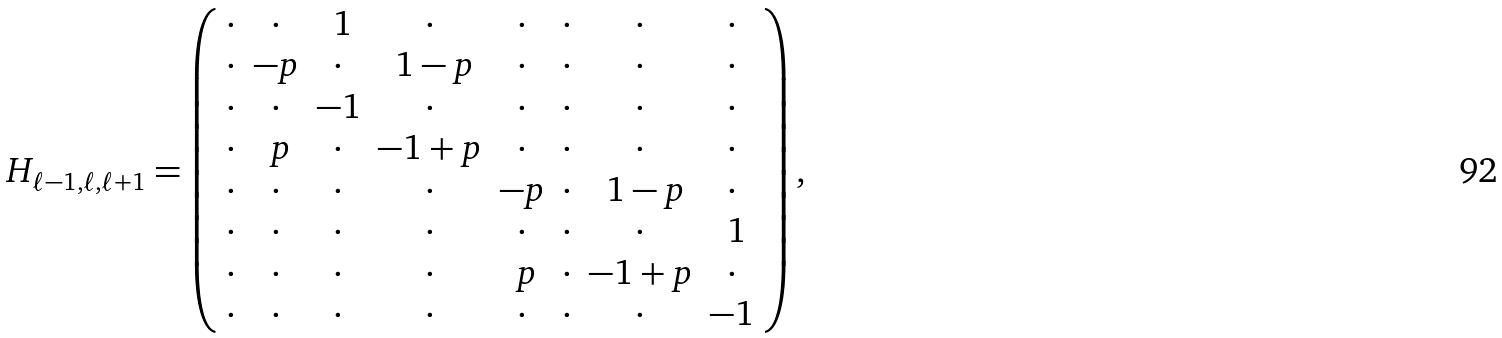Convert formula to latex. <formula><loc_0><loc_0><loc_500><loc_500>H _ { \ell - 1 , \ell , \ell + 1 } = \left ( \begin{array} { c c c c c c c c } \cdot & \cdot & \ 1 & \cdot & \cdot & \cdot & \cdot & \cdot \\ \cdot & - p & \cdot & \ 1 - p & \cdot & \cdot & \cdot & \cdot \\ \cdot & \cdot & - 1 & \cdot & \cdot & \cdot & \cdot & \cdot \\ \cdot & \ p & \cdot & - 1 + p & \cdot & \cdot & \cdot & \cdot \\ \cdot & \cdot & \cdot & \cdot & - p & \cdot & \ 1 - p & \cdot \\ \cdot & \cdot & \cdot & \cdot & \cdot & \cdot & \cdot & \ 1 \\ \cdot & \cdot & \cdot & \cdot & \ p & \cdot & - 1 + p & \cdot \\ \cdot & \cdot & \cdot & \cdot & \cdot & \cdot & \cdot & - 1 \end{array} \right ) ,</formula> 